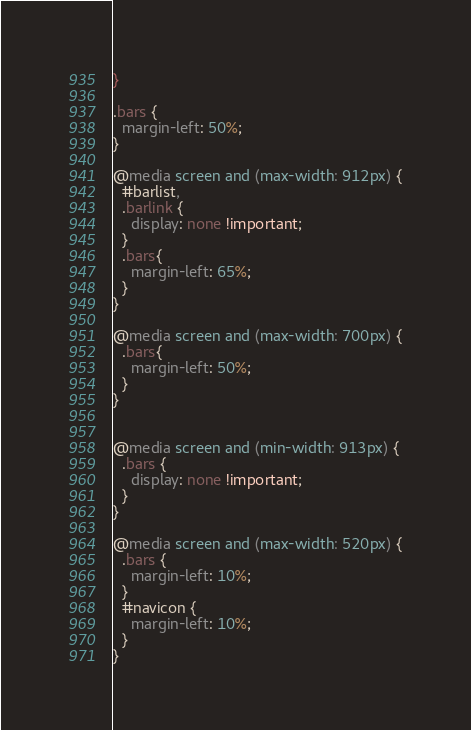Convert code to text. <code><loc_0><loc_0><loc_500><loc_500><_CSS_>}

.bars {
  margin-left: 50%;
}

@media screen and (max-width: 912px) {
  #barlist,
  .barlink {
    display: none !important;
  }
  .bars{
    margin-left: 65%;
  }
}

@media screen and (max-width: 700px) {
  .bars{
    margin-left: 50%;
  }
}


@media screen and (min-width: 913px) {
  .bars {
    display: none !important;
  }
}

@media screen and (max-width: 520px) {
  .bars {
    margin-left: 10%;
  }
  #navicon {
    margin-left: 10%;
  }
}
</code> 